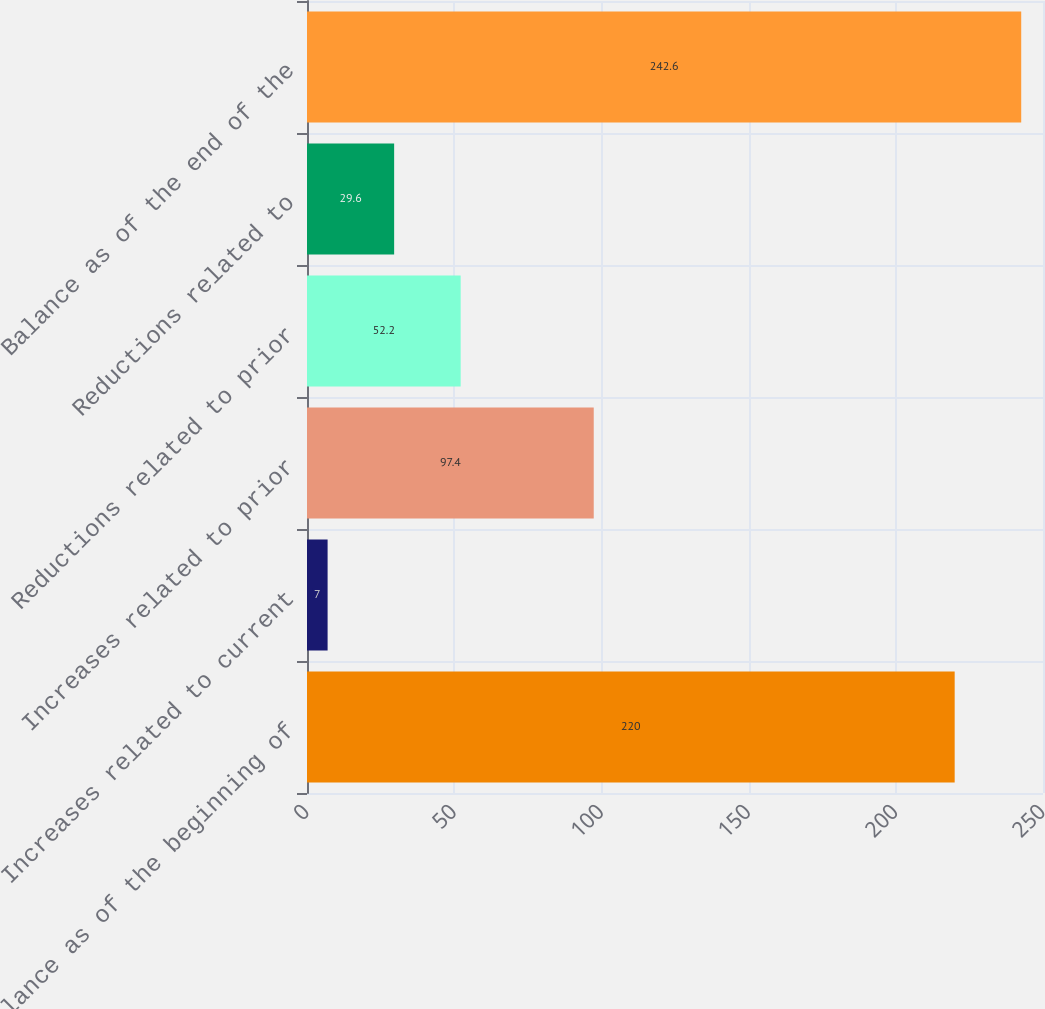Convert chart to OTSL. <chart><loc_0><loc_0><loc_500><loc_500><bar_chart><fcel>Balance as of the beginning of<fcel>Increases related to current<fcel>Increases related to prior<fcel>Reductions related to prior<fcel>Reductions related to<fcel>Balance as of the end of the<nl><fcel>220<fcel>7<fcel>97.4<fcel>52.2<fcel>29.6<fcel>242.6<nl></chart> 